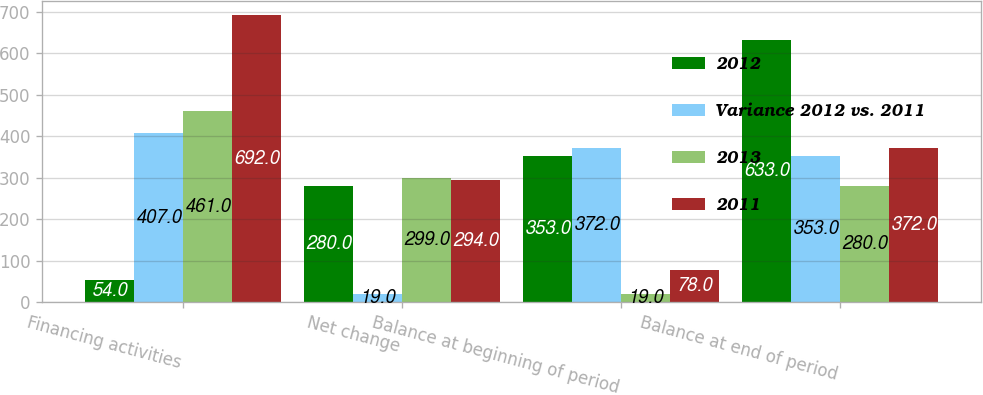<chart> <loc_0><loc_0><loc_500><loc_500><stacked_bar_chart><ecel><fcel>Financing activities<fcel>Net change<fcel>Balance at beginning of period<fcel>Balance at end of period<nl><fcel>2012<fcel>54<fcel>280<fcel>353<fcel>633<nl><fcel>Variance 2012 vs. 2011<fcel>407<fcel>19<fcel>372<fcel>353<nl><fcel>2013<fcel>461<fcel>299<fcel>19<fcel>280<nl><fcel>2011<fcel>692<fcel>294<fcel>78<fcel>372<nl></chart> 